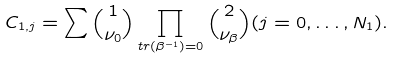<formula> <loc_0><loc_0><loc_500><loc_500>C _ { 1 , j } = \sum { 1 \choose \nu _ { 0 } } \prod _ { t r ( \beta ^ { - 1 } ) = 0 } { 2 \choose \nu _ { \beta } } ( j = 0 , \dots , N _ { 1 } ) .</formula> 